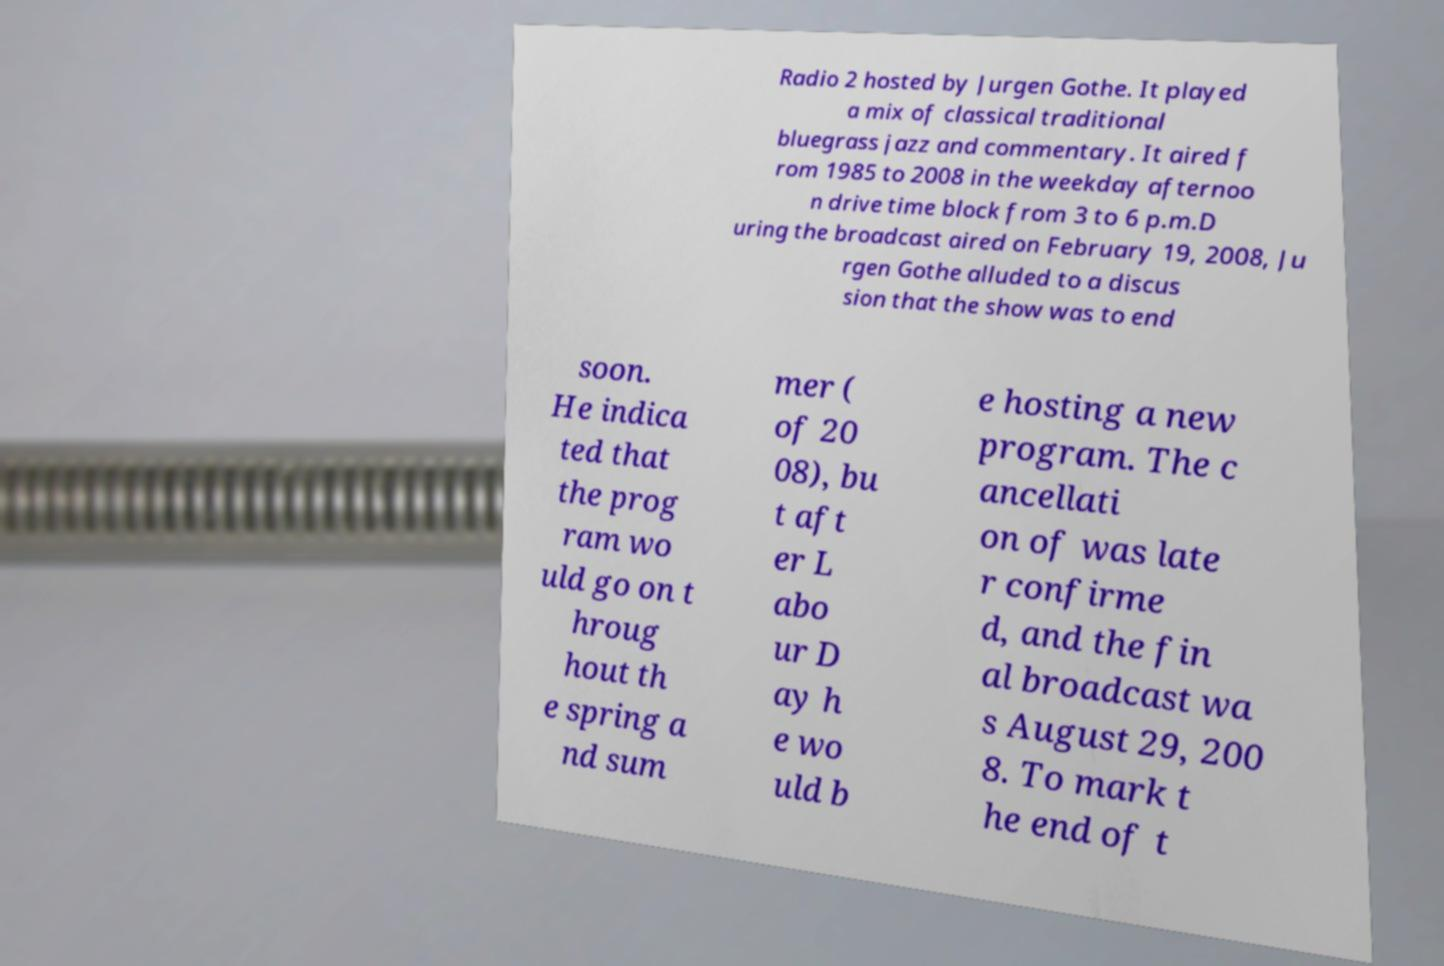Can you accurately transcribe the text from the provided image for me? Radio 2 hosted by Jurgen Gothe. It played a mix of classical traditional bluegrass jazz and commentary. It aired f rom 1985 to 2008 in the weekday afternoo n drive time block from 3 to 6 p.m.D uring the broadcast aired on February 19, 2008, Ju rgen Gothe alluded to a discus sion that the show was to end soon. He indica ted that the prog ram wo uld go on t hroug hout th e spring a nd sum mer ( of 20 08), bu t aft er L abo ur D ay h e wo uld b e hosting a new program. The c ancellati on of was late r confirme d, and the fin al broadcast wa s August 29, 200 8. To mark t he end of t 